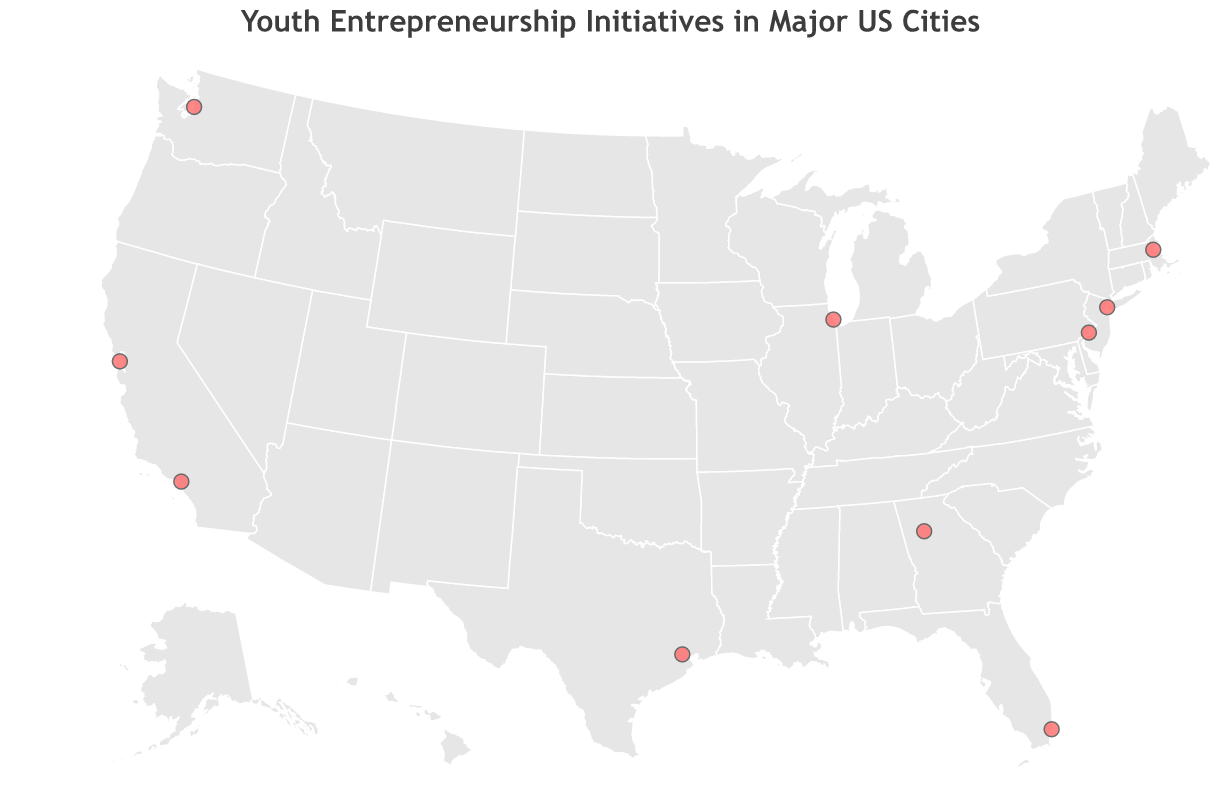What is the title of the geographic plot? The title is located at the top of the plot and describes what the figure is about.
Answer: Youth Entrepreneurship Initiatives in Major US Cities Which city hosts the "LA Tech Teens" initiative? Look for the "LA Tech Teens" initiative in the tooltip and check the corresponding city.
Answer: Los Angeles How many initiatives are focused on technology (including software development and green technology)? Identify the initiatives with focus areas related to technology: "LA Tech Teens" (Software Development) and "Bay Area Youth Ventures" (Green Technology).
Answer: 2 Which cities are located on the West Coast of the US? Look at the cities positioned along the western side of the US map, those would be San Francisco, Los Angeles, and Seattle.
Answer: San Francisco, Los Angeles, Seattle What is the focus area of the initiative in Atlanta? Find Atlanta on the map and look at the tooltip to determine the focus area of its initiative.
Answer: Social Enterprise Which initiative appears in Miami and what is its focus area? Locate Miami on the plot and check the tooltip for the name of the initiative and its focus area.
Answer: Miami Youth Makers, Sustainable Fashion Compare the geographic spread of initiatives between the East and West Coasts. How many are on each coast? Identify the cities on each coast and count the initiatives: East Coast (New York, Miami, Boston, Philadelphia) and West Coast (San Francisco, Los Angeles, Seattle).
Answer: East Coast: 4, West Coast: 3 What cities host initiatives focused on environmental or green solutions? Check for focus areas related to environmental or green solutions: "Seattle Youth Eco-Entrepreneurs" (Environmental Solutions) and "Bay Area Youth Ventures" (Green Technology).
Answer: Seattle, San Francisco How many initiatives are located in the central part of the United States? Identify initiatives in cities not on the East or West Coasts: Chicago, Houston.
Answer: 2 What is the northernmost city with a youth entrepreneurship initiative in this plot? Identify the city with the highest latitude value from the plot: Seattle (47.6062).
Answer: Seattle 